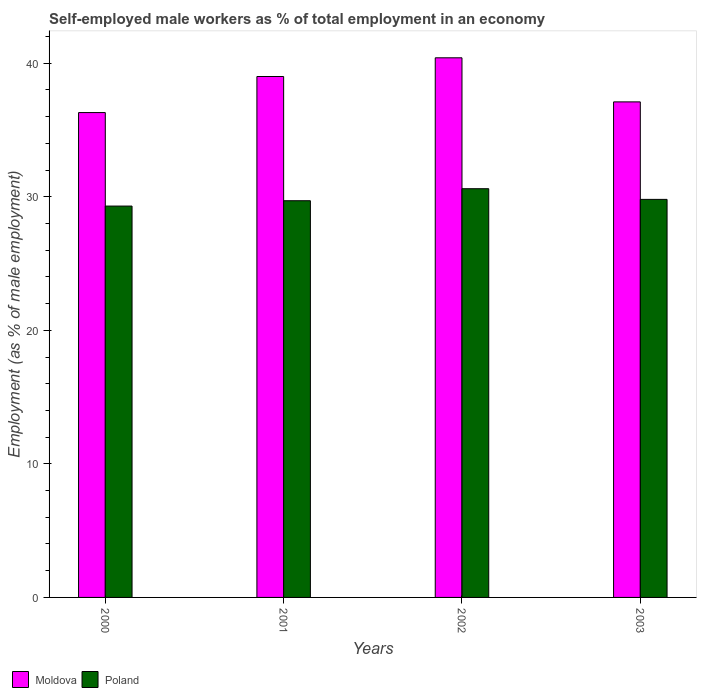Are the number of bars per tick equal to the number of legend labels?
Offer a very short reply. Yes. Are the number of bars on each tick of the X-axis equal?
Provide a succinct answer. Yes. How many bars are there on the 1st tick from the left?
Offer a terse response. 2. How many bars are there on the 2nd tick from the right?
Keep it short and to the point. 2. What is the percentage of self-employed male workers in Moldova in 2000?
Your answer should be compact. 36.3. Across all years, what is the maximum percentage of self-employed male workers in Moldova?
Give a very brief answer. 40.4. Across all years, what is the minimum percentage of self-employed male workers in Poland?
Keep it short and to the point. 29.3. In which year was the percentage of self-employed male workers in Poland minimum?
Ensure brevity in your answer.  2000. What is the total percentage of self-employed male workers in Moldova in the graph?
Your response must be concise. 152.8. What is the difference between the percentage of self-employed male workers in Moldova in 2001 and that in 2003?
Offer a very short reply. 1.9. What is the difference between the percentage of self-employed male workers in Poland in 2003 and the percentage of self-employed male workers in Moldova in 2001?
Your answer should be very brief. -9.2. What is the average percentage of self-employed male workers in Moldova per year?
Make the answer very short. 38.2. In the year 2000, what is the difference between the percentage of self-employed male workers in Moldova and percentage of self-employed male workers in Poland?
Make the answer very short. 7. In how many years, is the percentage of self-employed male workers in Moldova greater than 28 %?
Provide a short and direct response. 4. What is the ratio of the percentage of self-employed male workers in Moldova in 2000 to that in 2001?
Offer a terse response. 0.93. What is the difference between the highest and the second highest percentage of self-employed male workers in Poland?
Offer a very short reply. 0.8. What is the difference between the highest and the lowest percentage of self-employed male workers in Moldova?
Your answer should be very brief. 4.1. In how many years, is the percentage of self-employed male workers in Moldova greater than the average percentage of self-employed male workers in Moldova taken over all years?
Offer a terse response. 2. What does the 1st bar from the left in 2002 represents?
Provide a succinct answer. Moldova. What does the 1st bar from the right in 2000 represents?
Your answer should be very brief. Poland. How many years are there in the graph?
Keep it short and to the point. 4. What is the difference between two consecutive major ticks on the Y-axis?
Your response must be concise. 10. Where does the legend appear in the graph?
Your answer should be very brief. Bottom left. How are the legend labels stacked?
Ensure brevity in your answer.  Horizontal. What is the title of the graph?
Offer a terse response. Self-employed male workers as % of total employment in an economy. What is the label or title of the Y-axis?
Your response must be concise. Employment (as % of male employment). What is the Employment (as % of male employment) in Moldova in 2000?
Provide a succinct answer. 36.3. What is the Employment (as % of male employment) in Poland in 2000?
Ensure brevity in your answer.  29.3. What is the Employment (as % of male employment) in Moldova in 2001?
Provide a short and direct response. 39. What is the Employment (as % of male employment) in Poland in 2001?
Make the answer very short. 29.7. What is the Employment (as % of male employment) in Moldova in 2002?
Ensure brevity in your answer.  40.4. What is the Employment (as % of male employment) in Poland in 2002?
Give a very brief answer. 30.6. What is the Employment (as % of male employment) of Moldova in 2003?
Provide a short and direct response. 37.1. What is the Employment (as % of male employment) of Poland in 2003?
Your answer should be very brief. 29.8. Across all years, what is the maximum Employment (as % of male employment) in Moldova?
Make the answer very short. 40.4. Across all years, what is the maximum Employment (as % of male employment) in Poland?
Keep it short and to the point. 30.6. Across all years, what is the minimum Employment (as % of male employment) in Moldova?
Your answer should be compact. 36.3. Across all years, what is the minimum Employment (as % of male employment) of Poland?
Keep it short and to the point. 29.3. What is the total Employment (as % of male employment) in Moldova in the graph?
Your answer should be compact. 152.8. What is the total Employment (as % of male employment) in Poland in the graph?
Make the answer very short. 119.4. What is the difference between the Employment (as % of male employment) in Poland in 2000 and that in 2001?
Provide a short and direct response. -0.4. What is the difference between the Employment (as % of male employment) in Poland in 2000 and that in 2002?
Offer a very short reply. -1.3. What is the difference between the Employment (as % of male employment) of Moldova in 2000 and that in 2003?
Offer a very short reply. -0.8. What is the difference between the Employment (as % of male employment) in Poland in 2000 and that in 2003?
Offer a terse response. -0.5. What is the average Employment (as % of male employment) in Moldova per year?
Your answer should be very brief. 38.2. What is the average Employment (as % of male employment) of Poland per year?
Give a very brief answer. 29.85. In the year 2002, what is the difference between the Employment (as % of male employment) of Moldova and Employment (as % of male employment) of Poland?
Offer a very short reply. 9.8. In the year 2003, what is the difference between the Employment (as % of male employment) of Moldova and Employment (as % of male employment) of Poland?
Your answer should be compact. 7.3. What is the ratio of the Employment (as % of male employment) of Moldova in 2000 to that in 2001?
Your answer should be very brief. 0.93. What is the ratio of the Employment (as % of male employment) of Poland in 2000 to that in 2001?
Offer a terse response. 0.99. What is the ratio of the Employment (as % of male employment) in Moldova in 2000 to that in 2002?
Provide a succinct answer. 0.9. What is the ratio of the Employment (as % of male employment) in Poland in 2000 to that in 2002?
Provide a succinct answer. 0.96. What is the ratio of the Employment (as % of male employment) in Moldova in 2000 to that in 2003?
Provide a succinct answer. 0.98. What is the ratio of the Employment (as % of male employment) in Poland in 2000 to that in 2003?
Offer a terse response. 0.98. What is the ratio of the Employment (as % of male employment) of Moldova in 2001 to that in 2002?
Offer a terse response. 0.97. What is the ratio of the Employment (as % of male employment) in Poland in 2001 to that in 2002?
Give a very brief answer. 0.97. What is the ratio of the Employment (as % of male employment) of Moldova in 2001 to that in 2003?
Offer a very short reply. 1.05. What is the ratio of the Employment (as % of male employment) of Poland in 2001 to that in 2003?
Provide a succinct answer. 1. What is the ratio of the Employment (as % of male employment) of Moldova in 2002 to that in 2003?
Your answer should be compact. 1.09. What is the ratio of the Employment (as % of male employment) of Poland in 2002 to that in 2003?
Your answer should be very brief. 1.03. What is the difference between the highest and the second highest Employment (as % of male employment) in Moldova?
Ensure brevity in your answer.  1.4. What is the difference between the highest and the lowest Employment (as % of male employment) in Moldova?
Your answer should be very brief. 4.1. What is the difference between the highest and the lowest Employment (as % of male employment) of Poland?
Your answer should be very brief. 1.3. 